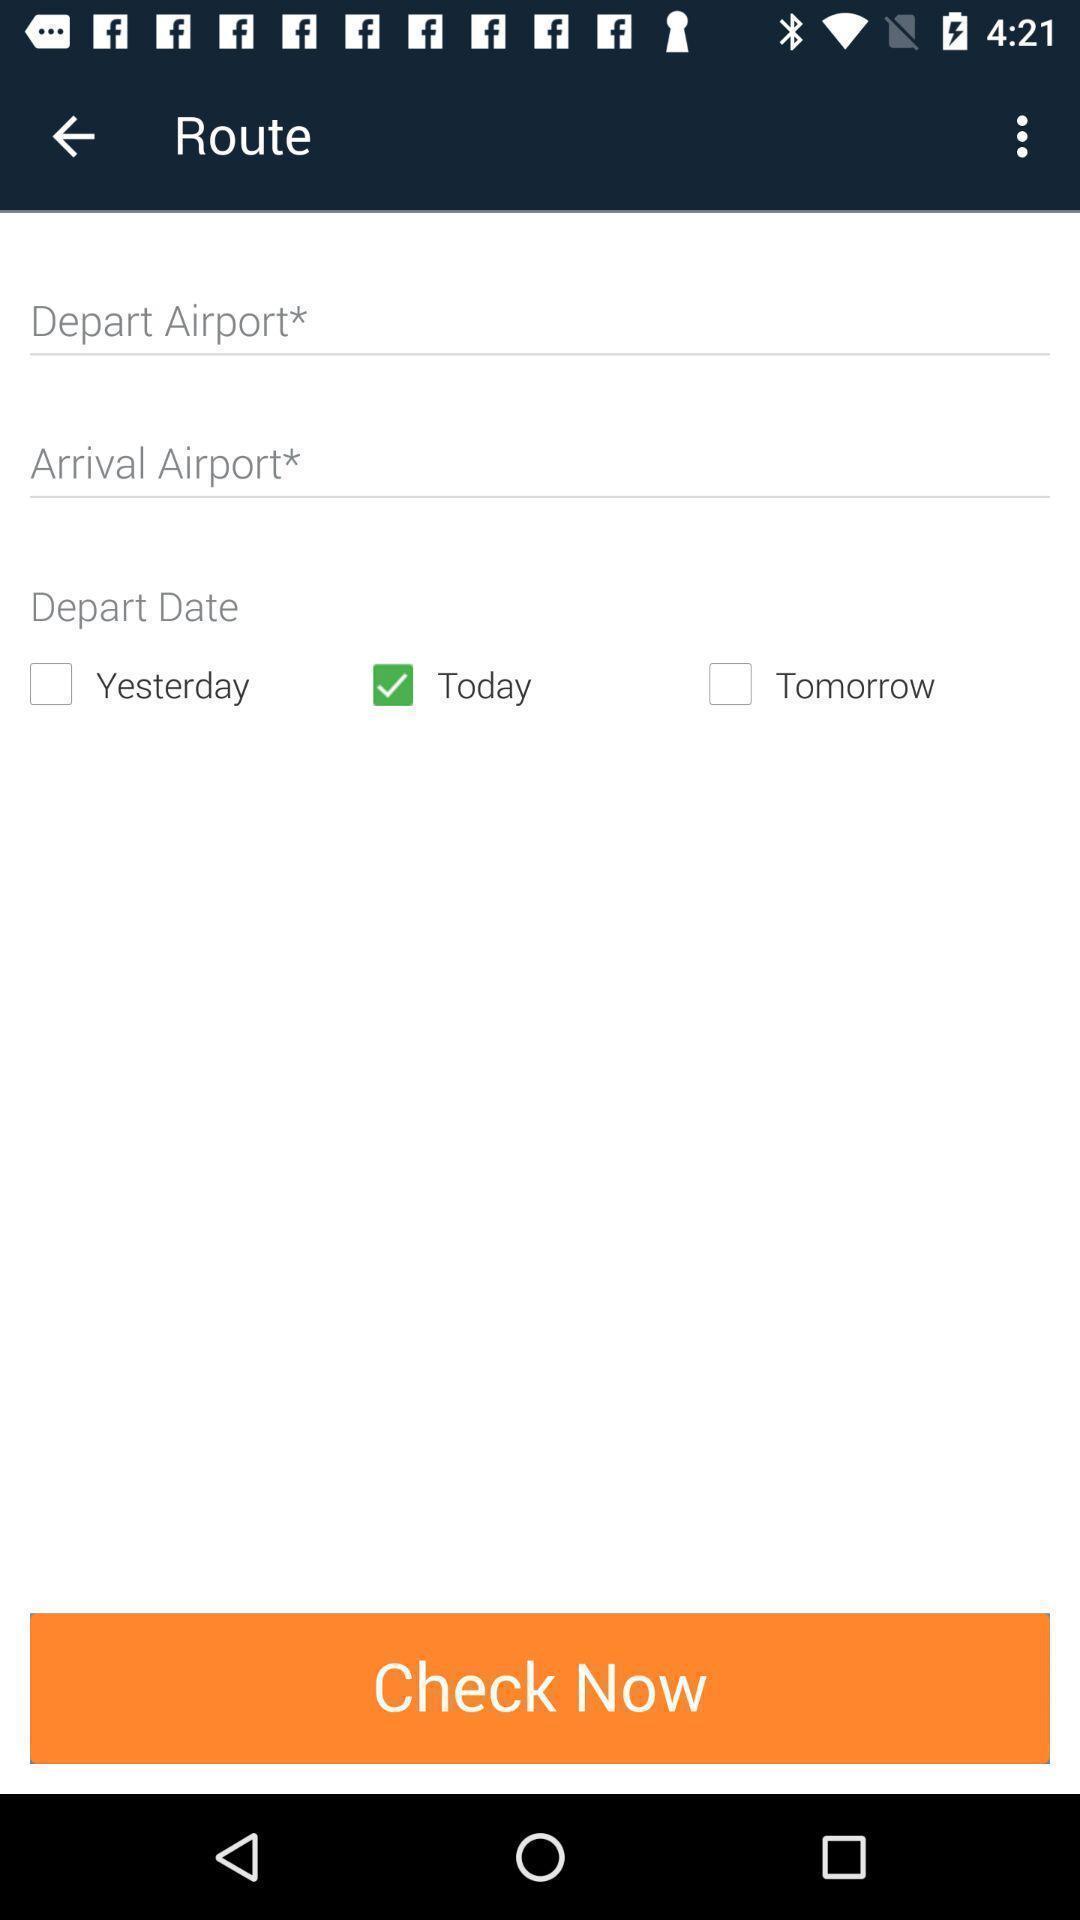Tell me what you see in this picture. Showing to add route details in travel app. 